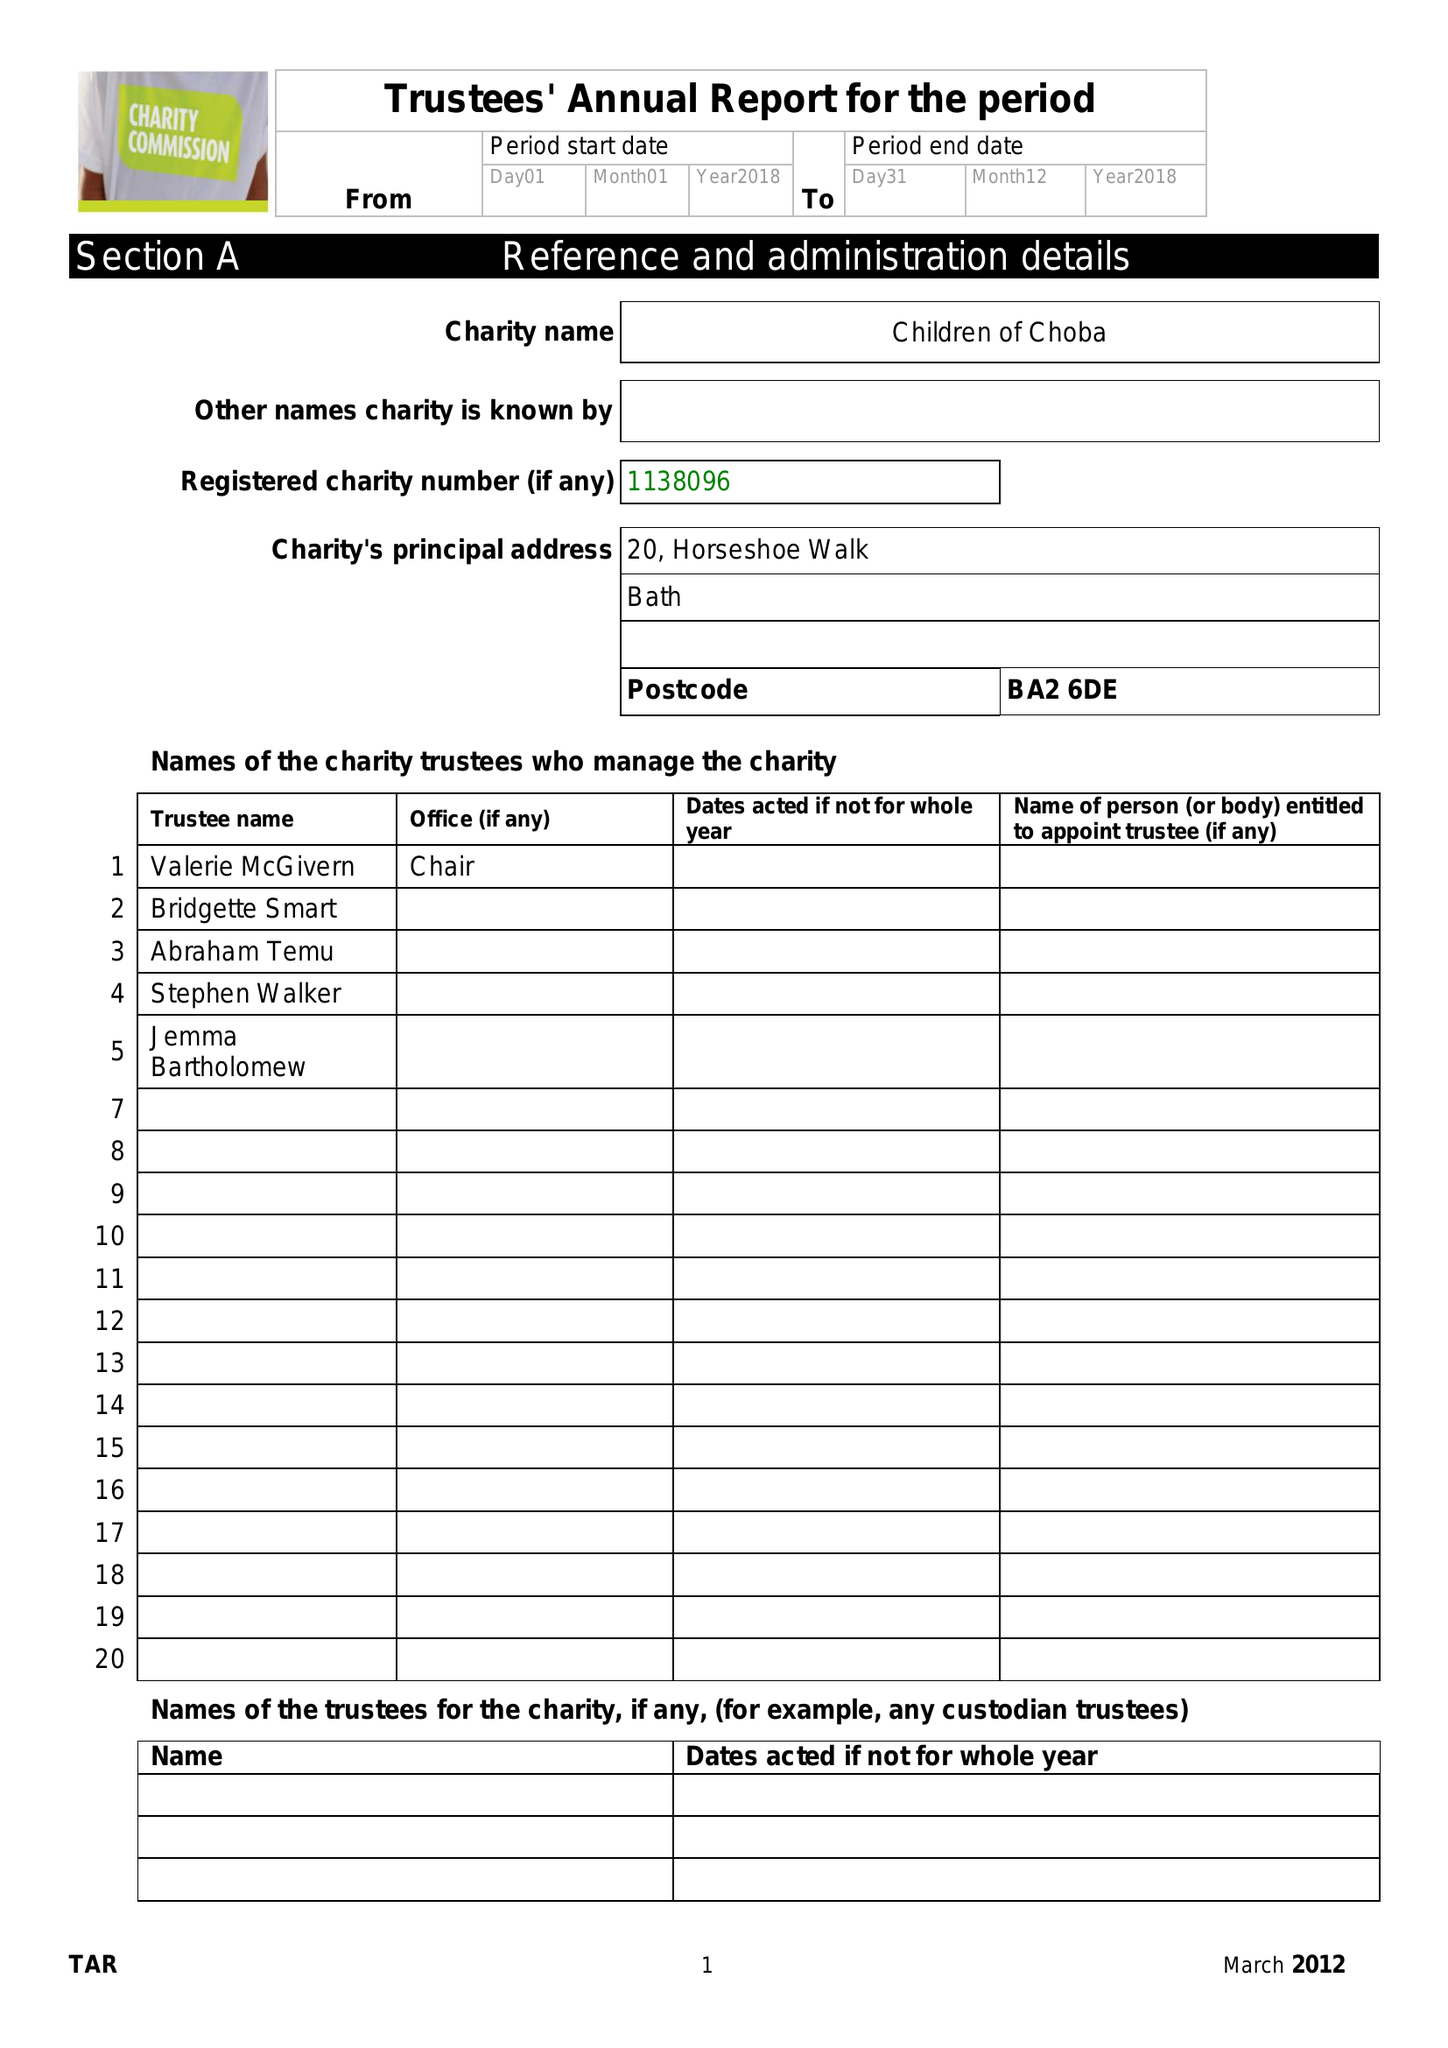What is the value for the charity_number?
Answer the question using a single word or phrase. 1138096 